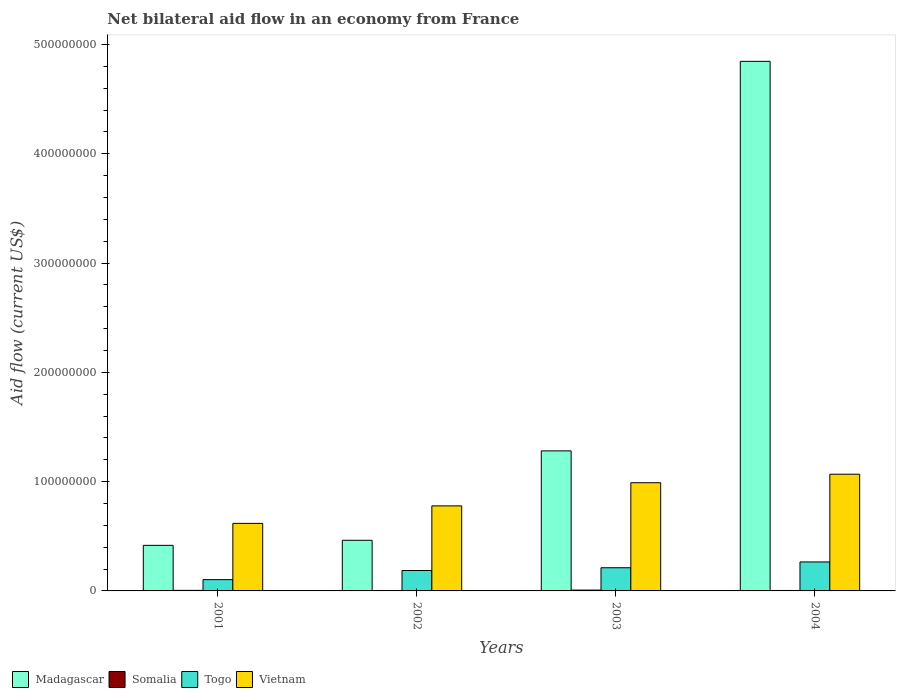How many different coloured bars are there?
Offer a very short reply. 4. How many groups of bars are there?
Your response must be concise. 4. Are the number of bars per tick equal to the number of legend labels?
Provide a succinct answer. Yes. How many bars are there on the 3rd tick from the left?
Keep it short and to the point. 4. How many bars are there on the 4th tick from the right?
Offer a very short reply. 4. In how many cases, is the number of bars for a given year not equal to the number of legend labels?
Ensure brevity in your answer.  0. What is the net bilateral aid flow in Madagascar in 2001?
Ensure brevity in your answer.  4.17e+07. Across all years, what is the maximum net bilateral aid flow in Madagascar?
Offer a very short reply. 4.85e+08. Across all years, what is the minimum net bilateral aid flow in Madagascar?
Make the answer very short. 4.17e+07. What is the total net bilateral aid flow in Somalia in the graph?
Offer a terse response. 2.05e+06. What is the difference between the net bilateral aid flow in Togo in 2001 and that in 2002?
Offer a very short reply. -8.35e+06. What is the difference between the net bilateral aid flow in Vietnam in 2003 and the net bilateral aid flow in Togo in 2002?
Your answer should be very brief. 8.03e+07. What is the average net bilateral aid flow in Somalia per year?
Provide a short and direct response. 5.12e+05. In the year 2003, what is the difference between the net bilateral aid flow in Vietnam and net bilateral aid flow in Somalia?
Your answer should be compact. 9.82e+07. What is the ratio of the net bilateral aid flow in Madagascar in 2002 to that in 2003?
Provide a short and direct response. 0.36. Is the net bilateral aid flow in Madagascar in 2002 less than that in 2003?
Provide a short and direct response. Yes. Is the difference between the net bilateral aid flow in Vietnam in 2002 and 2004 greater than the difference between the net bilateral aid flow in Somalia in 2002 and 2004?
Offer a terse response. No. What is the difference between the highest and the lowest net bilateral aid flow in Madagascar?
Offer a terse response. 4.43e+08. What does the 4th bar from the left in 2002 represents?
Provide a succinct answer. Vietnam. What does the 2nd bar from the right in 2001 represents?
Keep it short and to the point. Togo. Is it the case that in every year, the sum of the net bilateral aid flow in Madagascar and net bilateral aid flow in Vietnam is greater than the net bilateral aid flow in Togo?
Your answer should be very brief. Yes. How many bars are there?
Offer a very short reply. 16. What is the difference between two consecutive major ticks on the Y-axis?
Your answer should be very brief. 1.00e+08. Does the graph contain any zero values?
Make the answer very short. No. How many legend labels are there?
Offer a very short reply. 4. How are the legend labels stacked?
Offer a very short reply. Horizontal. What is the title of the graph?
Offer a terse response. Net bilateral aid flow in an economy from France. What is the Aid flow (current US$) of Madagascar in 2001?
Provide a succinct answer. 4.17e+07. What is the Aid flow (current US$) in Somalia in 2001?
Your answer should be compact. 5.00e+05. What is the Aid flow (current US$) in Togo in 2001?
Make the answer very short. 1.03e+07. What is the Aid flow (current US$) of Vietnam in 2001?
Your answer should be very brief. 6.18e+07. What is the Aid flow (current US$) of Madagascar in 2002?
Give a very brief answer. 4.63e+07. What is the Aid flow (current US$) in Somalia in 2002?
Make the answer very short. 3.90e+05. What is the Aid flow (current US$) in Togo in 2002?
Provide a succinct answer. 1.87e+07. What is the Aid flow (current US$) of Vietnam in 2002?
Offer a terse response. 7.78e+07. What is the Aid flow (current US$) of Madagascar in 2003?
Your answer should be compact. 1.28e+08. What is the Aid flow (current US$) of Somalia in 2003?
Offer a terse response. 7.60e+05. What is the Aid flow (current US$) in Togo in 2003?
Offer a terse response. 2.12e+07. What is the Aid flow (current US$) of Vietnam in 2003?
Offer a very short reply. 9.90e+07. What is the Aid flow (current US$) in Madagascar in 2004?
Ensure brevity in your answer.  4.85e+08. What is the Aid flow (current US$) of Somalia in 2004?
Offer a very short reply. 4.00e+05. What is the Aid flow (current US$) of Togo in 2004?
Keep it short and to the point. 2.65e+07. What is the Aid flow (current US$) in Vietnam in 2004?
Your response must be concise. 1.07e+08. Across all years, what is the maximum Aid flow (current US$) in Madagascar?
Provide a succinct answer. 4.85e+08. Across all years, what is the maximum Aid flow (current US$) of Somalia?
Give a very brief answer. 7.60e+05. Across all years, what is the maximum Aid flow (current US$) of Togo?
Ensure brevity in your answer.  2.65e+07. Across all years, what is the maximum Aid flow (current US$) of Vietnam?
Your answer should be very brief. 1.07e+08. Across all years, what is the minimum Aid flow (current US$) in Madagascar?
Provide a short and direct response. 4.17e+07. Across all years, what is the minimum Aid flow (current US$) in Togo?
Provide a short and direct response. 1.03e+07. Across all years, what is the minimum Aid flow (current US$) in Vietnam?
Your answer should be compact. 6.18e+07. What is the total Aid flow (current US$) of Madagascar in the graph?
Make the answer very short. 7.01e+08. What is the total Aid flow (current US$) of Somalia in the graph?
Offer a terse response. 2.05e+06. What is the total Aid flow (current US$) in Togo in the graph?
Your answer should be very brief. 7.67e+07. What is the total Aid flow (current US$) in Vietnam in the graph?
Offer a terse response. 3.45e+08. What is the difference between the Aid flow (current US$) in Madagascar in 2001 and that in 2002?
Your answer should be very brief. -4.64e+06. What is the difference between the Aid flow (current US$) of Togo in 2001 and that in 2002?
Keep it short and to the point. -8.35e+06. What is the difference between the Aid flow (current US$) of Vietnam in 2001 and that in 2002?
Make the answer very short. -1.60e+07. What is the difference between the Aid flow (current US$) of Madagascar in 2001 and that in 2003?
Provide a short and direct response. -8.64e+07. What is the difference between the Aid flow (current US$) in Somalia in 2001 and that in 2003?
Your answer should be compact. -2.60e+05. What is the difference between the Aid flow (current US$) in Togo in 2001 and that in 2003?
Your answer should be compact. -1.09e+07. What is the difference between the Aid flow (current US$) of Vietnam in 2001 and that in 2003?
Your answer should be compact. -3.72e+07. What is the difference between the Aid flow (current US$) of Madagascar in 2001 and that in 2004?
Your response must be concise. -4.43e+08. What is the difference between the Aid flow (current US$) of Somalia in 2001 and that in 2004?
Provide a short and direct response. 1.00e+05. What is the difference between the Aid flow (current US$) of Togo in 2001 and that in 2004?
Ensure brevity in your answer.  -1.62e+07. What is the difference between the Aid flow (current US$) in Vietnam in 2001 and that in 2004?
Your answer should be compact. -4.50e+07. What is the difference between the Aid flow (current US$) in Madagascar in 2002 and that in 2003?
Your response must be concise. -8.18e+07. What is the difference between the Aid flow (current US$) of Somalia in 2002 and that in 2003?
Your answer should be compact. -3.70e+05. What is the difference between the Aid flow (current US$) of Togo in 2002 and that in 2003?
Your answer should be compact. -2.52e+06. What is the difference between the Aid flow (current US$) of Vietnam in 2002 and that in 2003?
Give a very brief answer. -2.12e+07. What is the difference between the Aid flow (current US$) of Madagascar in 2002 and that in 2004?
Your answer should be compact. -4.38e+08. What is the difference between the Aid flow (current US$) of Somalia in 2002 and that in 2004?
Keep it short and to the point. -10000. What is the difference between the Aid flow (current US$) of Togo in 2002 and that in 2004?
Make the answer very short. -7.83e+06. What is the difference between the Aid flow (current US$) in Vietnam in 2002 and that in 2004?
Your answer should be compact. -2.90e+07. What is the difference between the Aid flow (current US$) in Madagascar in 2003 and that in 2004?
Provide a short and direct response. -3.56e+08. What is the difference between the Aid flow (current US$) in Somalia in 2003 and that in 2004?
Ensure brevity in your answer.  3.60e+05. What is the difference between the Aid flow (current US$) in Togo in 2003 and that in 2004?
Your answer should be very brief. -5.31e+06. What is the difference between the Aid flow (current US$) of Vietnam in 2003 and that in 2004?
Keep it short and to the point. -7.77e+06. What is the difference between the Aid flow (current US$) of Madagascar in 2001 and the Aid flow (current US$) of Somalia in 2002?
Your response must be concise. 4.13e+07. What is the difference between the Aid flow (current US$) of Madagascar in 2001 and the Aid flow (current US$) of Togo in 2002?
Keep it short and to the point. 2.30e+07. What is the difference between the Aid flow (current US$) in Madagascar in 2001 and the Aid flow (current US$) in Vietnam in 2002?
Give a very brief answer. -3.61e+07. What is the difference between the Aid flow (current US$) in Somalia in 2001 and the Aid flow (current US$) in Togo in 2002?
Provide a succinct answer. -1.82e+07. What is the difference between the Aid flow (current US$) in Somalia in 2001 and the Aid flow (current US$) in Vietnam in 2002?
Provide a short and direct response. -7.73e+07. What is the difference between the Aid flow (current US$) in Togo in 2001 and the Aid flow (current US$) in Vietnam in 2002?
Make the answer very short. -6.75e+07. What is the difference between the Aid flow (current US$) of Madagascar in 2001 and the Aid flow (current US$) of Somalia in 2003?
Keep it short and to the point. 4.09e+07. What is the difference between the Aid flow (current US$) in Madagascar in 2001 and the Aid flow (current US$) in Togo in 2003?
Provide a short and direct response. 2.05e+07. What is the difference between the Aid flow (current US$) in Madagascar in 2001 and the Aid flow (current US$) in Vietnam in 2003?
Offer a terse response. -5.73e+07. What is the difference between the Aid flow (current US$) of Somalia in 2001 and the Aid flow (current US$) of Togo in 2003?
Give a very brief answer. -2.07e+07. What is the difference between the Aid flow (current US$) in Somalia in 2001 and the Aid flow (current US$) in Vietnam in 2003?
Your response must be concise. -9.85e+07. What is the difference between the Aid flow (current US$) in Togo in 2001 and the Aid flow (current US$) in Vietnam in 2003?
Keep it short and to the point. -8.87e+07. What is the difference between the Aid flow (current US$) of Madagascar in 2001 and the Aid flow (current US$) of Somalia in 2004?
Give a very brief answer. 4.13e+07. What is the difference between the Aid flow (current US$) of Madagascar in 2001 and the Aid flow (current US$) of Togo in 2004?
Keep it short and to the point. 1.52e+07. What is the difference between the Aid flow (current US$) in Madagascar in 2001 and the Aid flow (current US$) in Vietnam in 2004?
Offer a very short reply. -6.51e+07. What is the difference between the Aid flow (current US$) of Somalia in 2001 and the Aid flow (current US$) of Togo in 2004?
Provide a succinct answer. -2.60e+07. What is the difference between the Aid flow (current US$) of Somalia in 2001 and the Aid flow (current US$) of Vietnam in 2004?
Provide a short and direct response. -1.06e+08. What is the difference between the Aid flow (current US$) in Togo in 2001 and the Aid flow (current US$) in Vietnam in 2004?
Ensure brevity in your answer.  -9.64e+07. What is the difference between the Aid flow (current US$) of Madagascar in 2002 and the Aid flow (current US$) of Somalia in 2003?
Your response must be concise. 4.56e+07. What is the difference between the Aid flow (current US$) in Madagascar in 2002 and the Aid flow (current US$) in Togo in 2003?
Offer a very short reply. 2.51e+07. What is the difference between the Aid flow (current US$) in Madagascar in 2002 and the Aid flow (current US$) in Vietnam in 2003?
Keep it short and to the point. -5.27e+07. What is the difference between the Aid flow (current US$) in Somalia in 2002 and the Aid flow (current US$) in Togo in 2003?
Give a very brief answer. -2.08e+07. What is the difference between the Aid flow (current US$) in Somalia in 2002 and the Aid flow (current US$) in Vietnam in 2003?
Your response must be concise. -9.86e+07. What is the difference between the Aid flow (current US$) in Togo in 2002 and the Aid flow (current US$) in Vietnam in 2003?
Your answer should be compact. -8.03e+07. What is the difference between the Aid flow (current US$) of Madagascar in 2002 and the Aid flow (current US$) of Somalia in 2004?
Provide a short and direct response. 4.59e+07. What is the difference between the Aid flow (current US$) in Madagascar in 2002 and the Aid flow (current US$) in Togo in 2004?
Your answer should be compact. 1.98e+07. What is the difference between the Aid flow (current US$) of Madagascar in 2002 and the Aid flow (current US$) of Vietnam in 2004?
Your response must be concise. -6.04e+07. What is the difference between the Aid flow (current US$) of Somalia in 2002 and the Aid flow (current US$) of Togo in 2004?
Provide a short and direct response. -2.61e+07. What is the difference between the Aid flow (current US$) in Somalia in 2002 and the Aid flow (current US$) in Vietnam in 2004?
Provide a short and direct response. -1.06e+08. What is the difference between the Aid flow (current US$) in Togo in 2002 and the Aid flow (current US$) in Vietnam in 2004?
Give a very brief answer. -8.81e+07. What is the difference between the Aid flow (current US$) of Madagascar in 2003 and the Aid flow (current US$) of Somalia in 2004?
Keep it short and to the point. 1.28e+08. What is the difference between the Aid flow (current US$) of Madagascar in 2003 and the Aid flow (current US$) of Togo in 2004?
Give a very brief answer. 1.02e+08. What is the difference between the Aid flow (current US$) of Madagascar in 2003 and the Aid flow (current US$) of Vietnam in 2004?
Make the answer very short. 2.14e+07. What is the difference between the Aid flow (current US$) of Somalia in 2003 and the Aid flow (current US$) of Togo in 2004?
Offer a terse response. -2.58e+07. What is the difference between the Aid flow (current US$) in Somalia in 2003 and the Aid flow (current US$) in Vietnam in 2004?
Give a very brief answer. -1.06e+08. What is the difference between the Aid flow (current US$) of Togo in 2003 and the Aid flow (current US$) of Vietnam in 2004?
Offer a very short reply. -8.56e+07. What is the average Aid flow (current US$) of Madagascar per year?
Offer a very short reply. 1.75e+08. What is the average Aid flow (current US$) in Somalia per year?
Give a very brief answer. 5.12e+05. What is the average Aid flow (current US$) in Togo per year?
Your answer should be very brief. 1.92e+07. What is the average Aid flow (current US$) in Vietnam per year?
Your answer should be very brief. 8.63e+07. In the year 2001, what is the difference between the Aid flow (current US$) in Madagascar and Aid flow (current US$) in Somalia?
Your response must be concise. 4.12e+07. In the year 2001, what is the difference between the Aid flow (current US$) of Madagascar and Aid flow (current US$) of Togo?
Give a very brief answer. 3.14e+07. In the year 2001, what is the difference between the Aid flow (current US$) of Madagascar and Aid flow (current US$) of Vietnam?
Your answer should be compact. -2.01e+07. In the year 2001, what is the difference between the Aid flow (current US$) of Somalia and Aid flow (current US$) of Togo?
Your answer should be compact. -9.83e+06. In the year 2001, what is the difference between the Aid flow (current US$) of Somalia and Aid flow (current US$) of Vietnam?
Provide a short and direct response. -6.13e+07. In the year 2001, what is the difference between the Aid flow (current US$) in Togo and Aid flow (current US$) in Vietnam?
Your answer should be compact. -5.15e+07. In the year 2002, what is the difference between the Aid flow (current US$) of Madagascar and Aid flow (current US$) of Somalia?
Provide a succinct answer. 4.59e+07. In the year 2002, what is the difference between the Aid flow (current US$) of Madagascar and Aid flow (current US$) of Togo?
Offer a terse response. 2.76e+07. In the year 2002, what is the difference between the Aid flow (current US$) in Madagascar and Aid flow (current US$) in Vietnam?
Give a very brief answer. -3.15e+07. In the year 2002, what is the difference between the Aid flow (current US$) in Somalia and Aid flow (current US$) in Togo?
Make the answer very short. -1.83e+07. In the year 2002, what is the difference between the Aid flow (current US$) in Somalia and Aid flow (current US$) in Vietnam?
Make the answer very short. -7.74e+07. In the year 2002, what is the difference between the Aid flow (current US$) in Togo and Aid flow (current US$) in Vietnam?
Give a very brief answer. -5.91e+07. In the year 2003, what is the difference between the Aid flow (current US$) in Madagascar and Aid flow (current US$) in Somalia?
Give a very brief answer. 1.27e+08. In the year 2003, what is the difference between the Aid flow (current US$) of Madagascar and Aid flow (current US$) of Togo?
Your answer should be compact. 1.07e+08. In the year 2003, what is the difference between the Aid flow (current US$) of Madagascar and Aid flow (current US$) of Vietnam?
Make the answer very short. 2.91e+07. In the year 2003, what is the difference between the Aid flow (current US$) in Somalia and Aid flow (current US$) in Togo?
Provide a short and direct response. -2.04e+07. In the year 2003, what is the difference between the Aid flow (current US$) in Somalia and Aid flow (current US$) in Vietnam?
Provide a short and direct response. -9.82e+07. In the year 2003, what is the difference between the Aid flow (current US$) of Togo and Aid flow (current US$) of Vietnam?
Provide a short and direct response. -7.78e+07. In the year 2004, what is the difference between the Aid flow (current US$) in Madagascar and Aid flow (current US$) in Somalia?
Ensure brevity in your answer.  4.84e+08. In the year 2004, what is the difference between the Aid flow (current US$) of Madagascar and Aid flow (current US$) of Togo?
Your answer should be very brief. 4.58e+08. In the year 2004, what is the difference between the Aid flow (current US$) in Madagascar and Aid flow (current US$) in Vietnam?
Offer a very short reply. 3.78e+08. In the year 2004, what is the difference between the Aid flow (current US$) in Somalia and Aid flow (current US$) in Togo?
Your answer should be compact. -2.61e+07. In the year 2004, what is the difference between the Aid flow (current US$) of Somalia and Aid flow (current US$) of Vietnam?
Keep it short and to the point. -1.06e+08. In the year 2004, what is the difference between the Aid flow (current US$) of Togo and Aid flow (current US$) of Vietnam?
Keep it short and to the point. -8.03e+07. What is the ratio of the Aid flow (current US$) of Madagascar in 2001 to that in 2002?
Your answer should be compact. 0.9. What is the ratio of the Aid flow (current US$) of Somalia in 2001 to that in 2002?
Your answer should be very brief. 1.28. What is the ratio of the Aid flow (current US$) in Togo in 2001 to that in 2002?
Offer a very short reply. 0.55. What is the ratio of the Aid flow (current US$) in Vietnam in 2001 to that in 2002?
Provide a short and direct response. 0.79. What is the ratio of the Aid flow (current US$) of Madagascar in 2001 to that in 2003?
Provide a short and direct response. 0.33. What is the ratio of the Aid flow (current US$) of Somalia in 2001 to that in 2003?
Your response must be concise. 0.66. What is the ratio of the Aid flow (current US$) in Togo in 2001 to that in 2003?
Your answer should be very brief. 0.49. What is the ratio of the Aid flow (current US$) in Vietnam in 2001 to that in 2003?
Make the answer very short. 0.62. What is the ratio of the Aid flow (current US$) in Madagascar in 2001 to that in 2004?
Provide a succinct answer. 0.09. What is the ratio of the Aid flow (current US$) in Togo in 2001 to that in 2004?
Make the answer very short. 0.39. What is the ratio of the Aid flow (current US$) in Vietnam in 2001 to that in 2004?
Make the answer very short. 0.58. What is the ratio of the Aid flow (current US$) in Madagascar in 2002 to that in 2003?
Provide a short and direct response. 0.36. What is the ratio of the Aid flow (current US$) in Somalia in 2002 to that in 2003?
Provide a short and direct response. 0.51. What is the ratio of the Aid flow (current US$) of Togo in 2002 to that in 2003?
Keep it short and to the point. 0.88. What is the ratio of the Aid flow (current US$) in Vietnam in 2002 to that in 2003?
Offer a very short reply. 0.79. What is the ratio of the Aid flow (current US$) of Madagascar in 2002 to that in 2004?
Ensure brevity in your answer.  0.1. What is the ratio of the Aid flow (current US$) of Togo in 2002 to that in 2004?
Provide a short and direct response. 0.7. What is the ratio of the Aid flow (current US$) of Vietnam in 2002 to that in 2004?
Offer a very short reply. 0.73. What is the ratio of the Aid flow (current US$) in Madagascar in 2003 to that in 2004?
Provide a succinct answer. 0.26. What is the ratio of the Aid flow (current US$) of Togo in 2003 to that in 2004?
Your answer should be very brief. 0.8. What is the ratio of the Aid flow (current US$) of Vietnam in 2003 to that in 2004?
Keep it short and to the point. 0.93. What is the difference between the highest and the second highest Aid flow (current US$) in Madagascar?
Provide a succinct answer. 3.56e+08. What is the difference between the highest and the second highest Aid flow (current US$) in Togo?
Offer a very short reply. 5.31e+06. What is the difference between the highest and the second highest Aid flow (current US$) of Vietnam?
Ensure brevity in your answer.  7.77e+06. What is the difference between the highest and the lowest Aid flow (current US$) in Madagascar?
Your response must be concise. 4.43e+08. What is the difference between the highest and the lowest Aid flow (current US$) in Somalia?
Provide a succinct answer. 3.70e+05. What is the difference between the highest and the lowest Aid flow (current US$) in Togo?
Make the answer very short. 1.62e+07. What is the difference between the highest and the lowest Aid flow (current US$) in Vietnam?
Offer a terse response. 4.50e+07. 